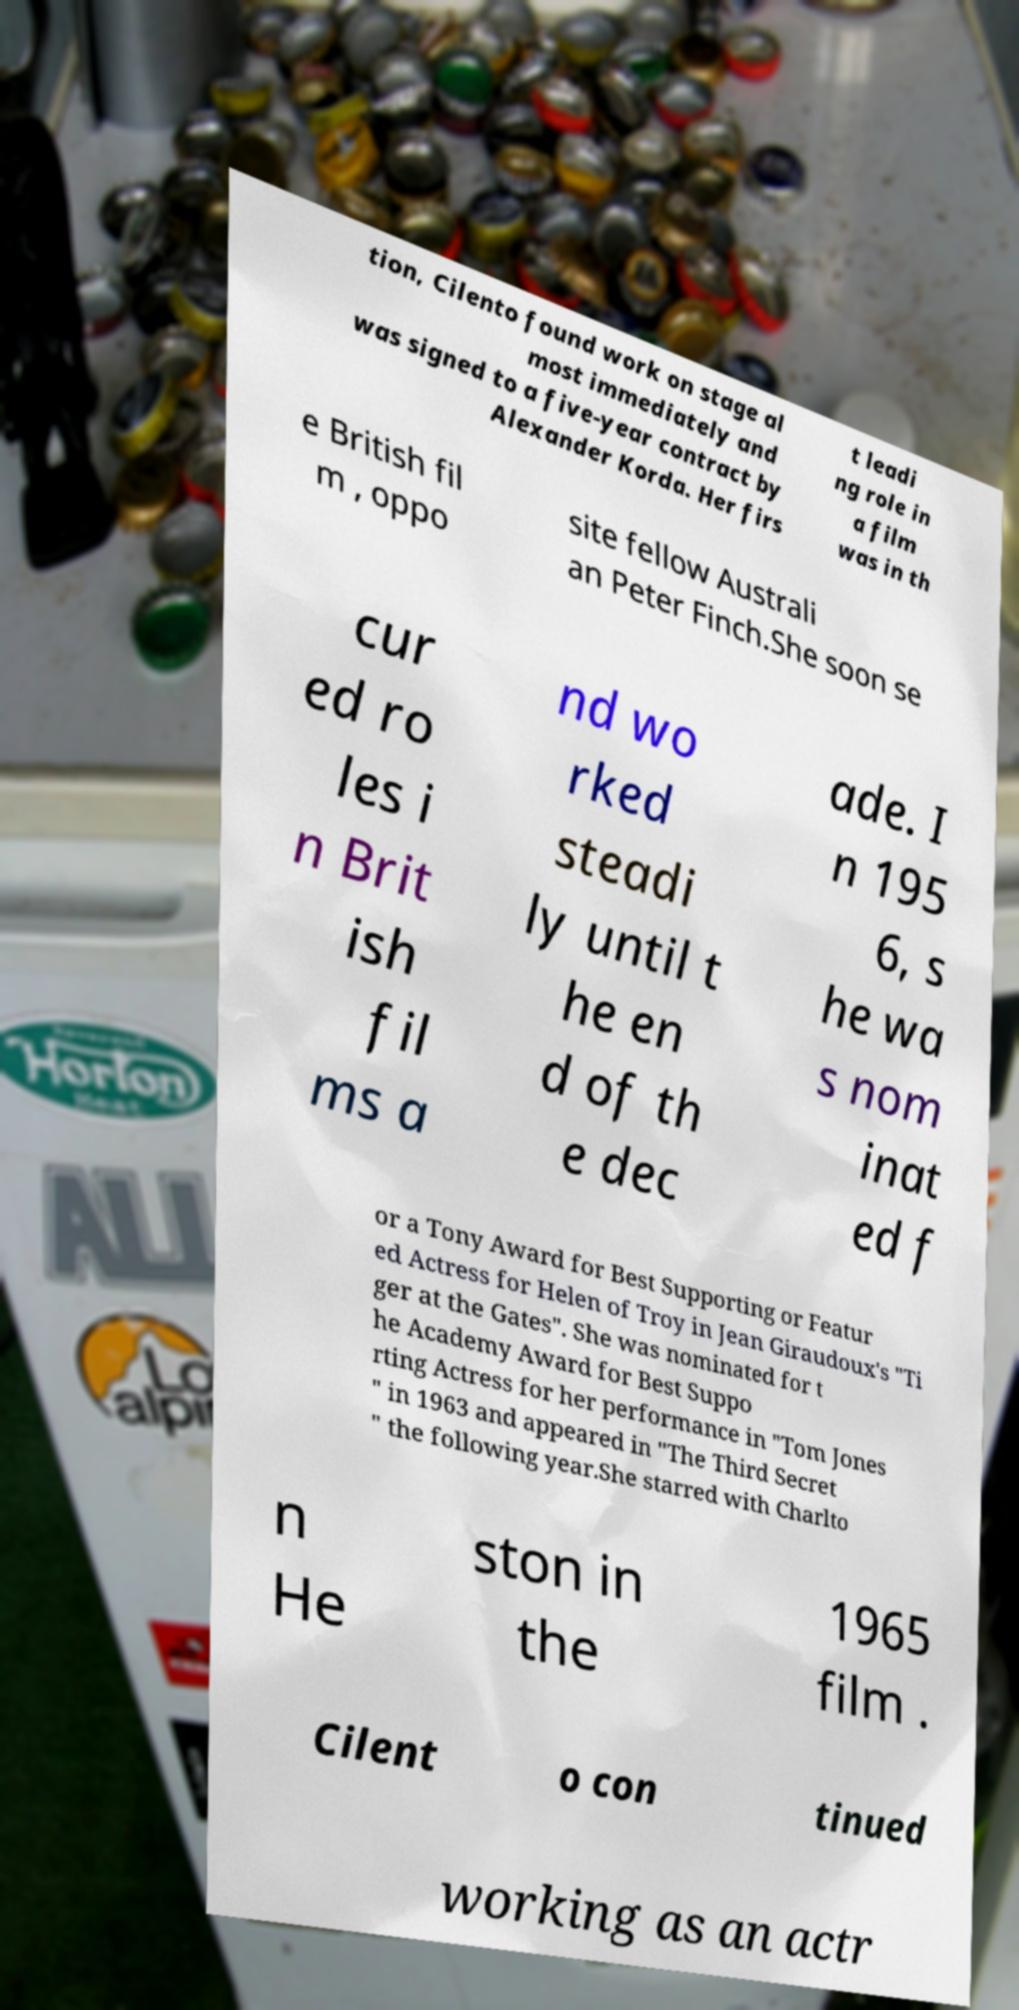For documentation purposes, I need the text within this image transcribed. Could you provide that? tion, Cilento found work on stage al most immediately and was signed to a five-year contract by Alexander Korda. Her firs t leadi ng role in a film was in th e British fil m , oppo site fellow Australi an Peter Finch.She soon se cur ed ro les i n Brit ish fil ms a nd wo rked steadi ly until t he en d of th e dec ade. I n 195 6, s he wa s nom inat ed f or a Tony Award for Best Supporting or Featur ed Actress for Helen of Troy in Jean Giraudoux's "Ti ger at the Gates". She was nominated for t he Academy Award for Best Suppo rting Actress for her performance in "Tom Jones " in 1963 and appeared in "The Third Secret " the following year.She starred with Charlto n He ston in the 1965 film . Cilent o con tinued working as an actr 